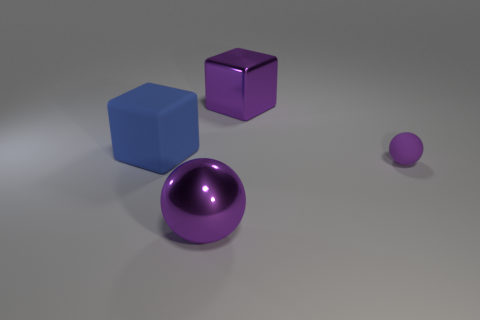There is a sphere in front of the small thing; is it the same color as the large metallic object that is behind the large metallic ball?
Give a very brief answer. Yes. Is the rubber sphere the same color as the big metallic sphere?
Your response must be concise. Yes. Do the purple object behind the big matte cube and the small object have the same shape?
Give a very brief answer. No. What number of purple objects are both left of the rubber sphere and in front of the purple metallic cube?
Your answer should be very brief. 1. What is the large purple block made of?
Offer a terse response. Metal. Are there any other things of the same color as the rubber cube?
Keep it short and to the point. No. Is the purple block made of the same material as the small purple object?
Offer a terse response. No. There is a large purple object that is in front of the big purple metallic thing that is behind the matte sphere; what number of large things are in front of it?
Ensure brevity in your answer.  0. How many gray metallic cubes are there?
Make the answer very short. 0. Are there fewer big purple shiny cubes that are on the right side of the large blue block than large metallic things that are in front of the big shiny ball?
Your response must be concise. No. 